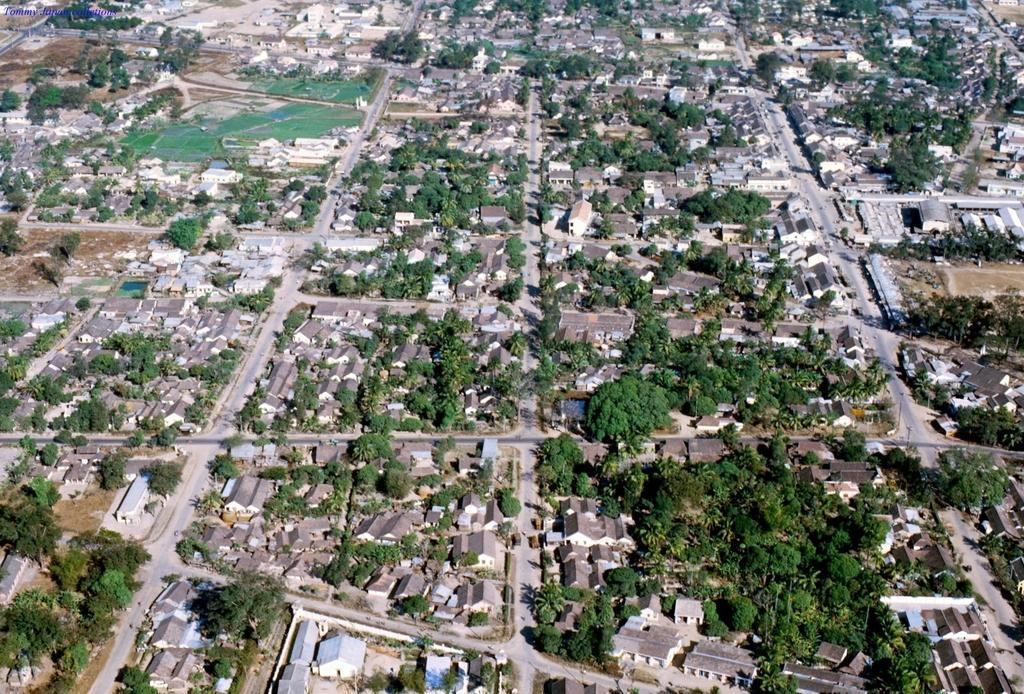How would you summarize this image in a sentence or two? In this picture we can see trees, buildings, roads and some objects. 